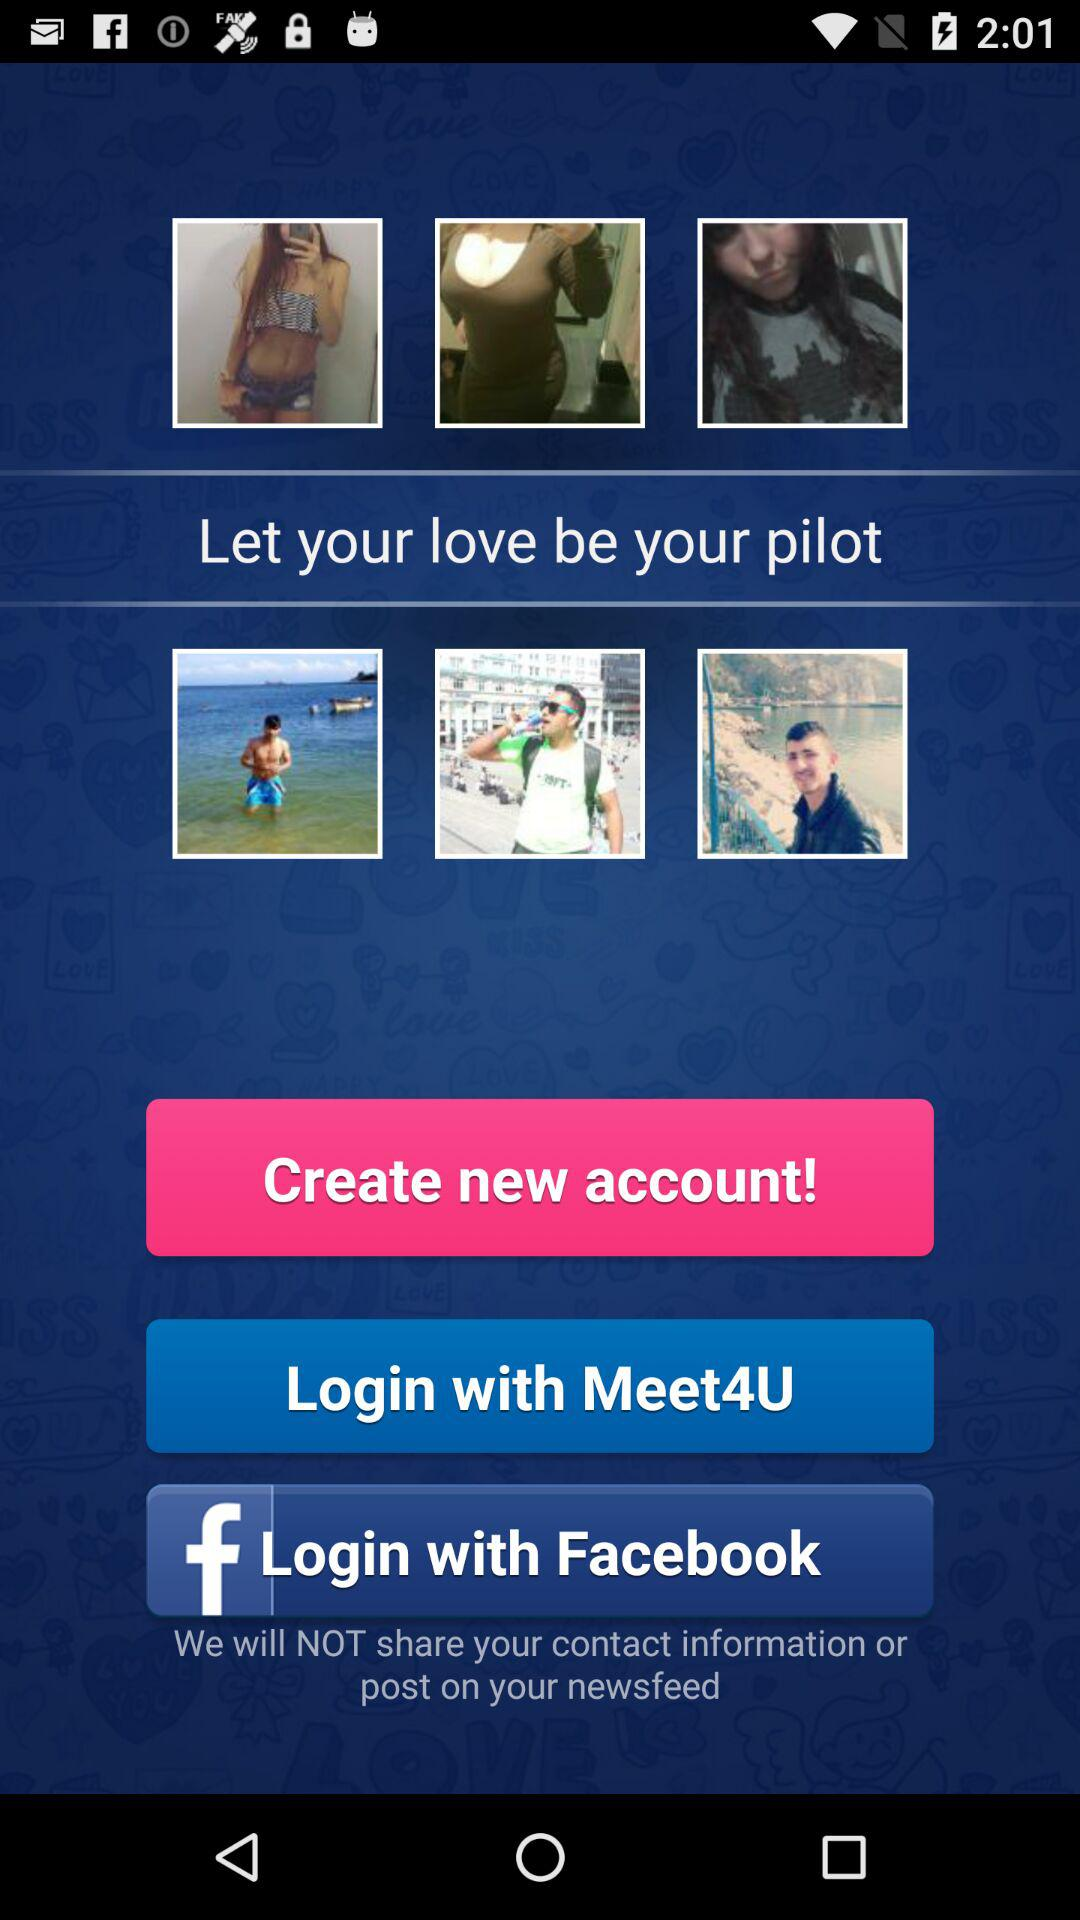Which application can be used to log in? The applications that can be used to log in are "Meet4U" and "Facebook". 